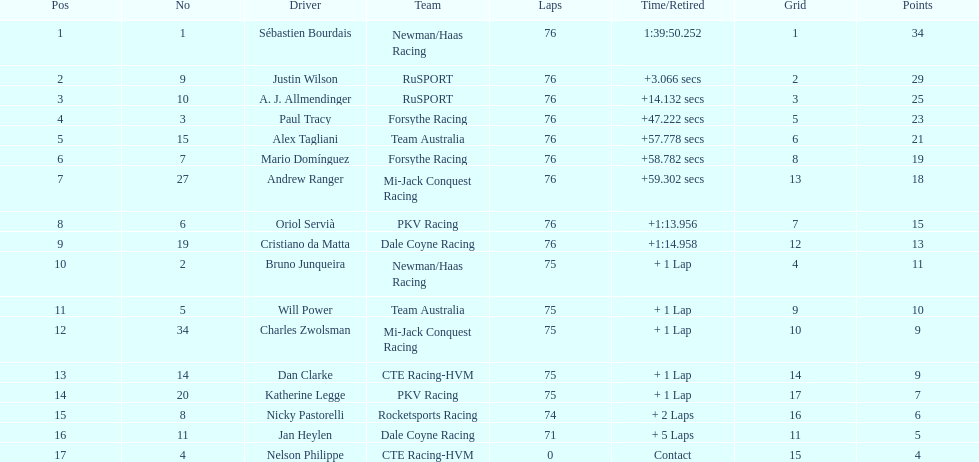Among the drivers, who has the minimum points? Nelson Philippe. 